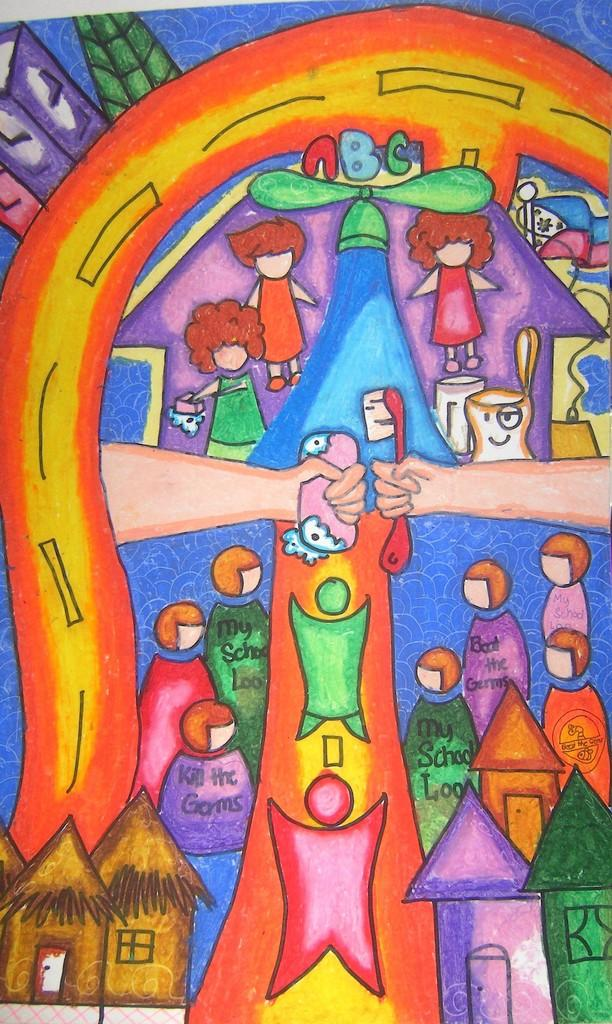What is the main subject of the image? There is a painting in the image. How many horses are depicted in the painting? There is no information about horses or any other specific elements within the painting, as only the fact that there is a painting in the image is provided. 